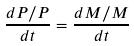<formula> <loc_0><loc_0><loc_500><loc_500>\frac { d P / P } { d t } = \frac { d M / M } { d t }</formula> 